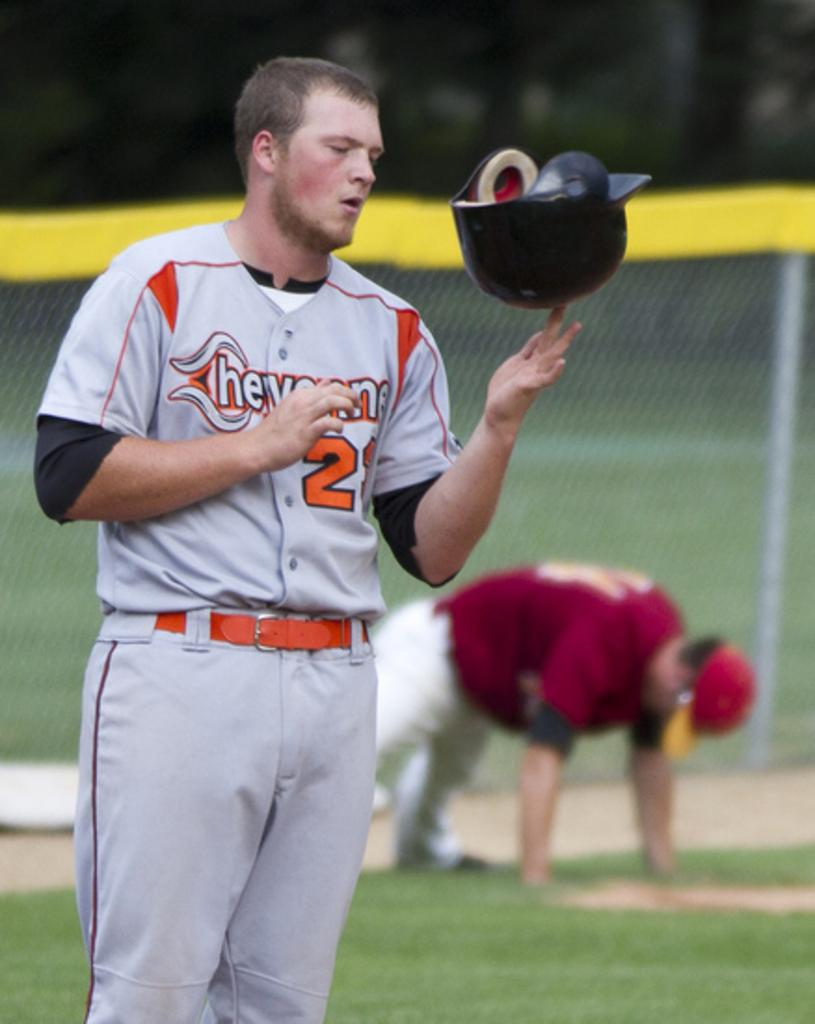<image>
Write a terse but informative summary of the picture. hevens baseball player twirling his helmet on his fingertip 